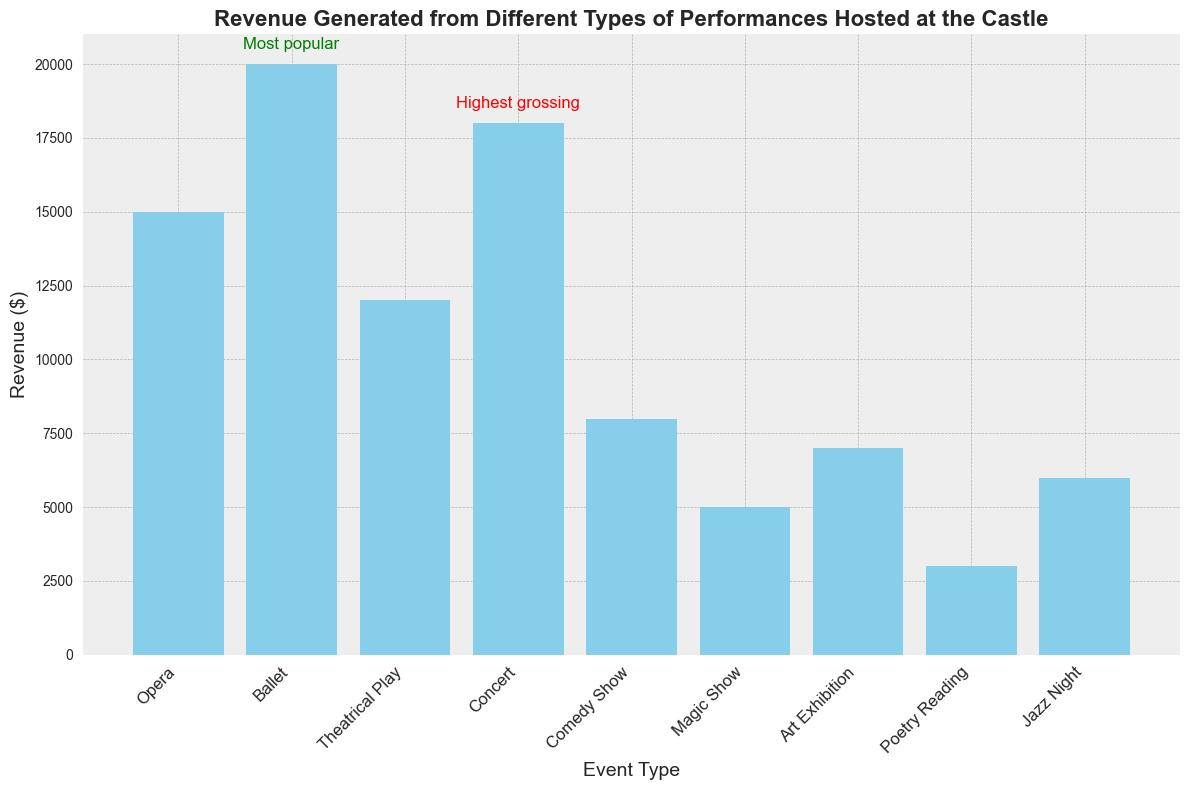Which event type generated the most revenue? By observing the heights of the bars, the Ballet event has the tallest bar indicating it generated the most revenue.
Answer: Ballet What notes are associated with the highest grossing event? The highest grossing event, Ballet, has a note indicated with "Most popular" in green text above its bar.
Answer: Most popular How does the revenue of the Concert compare to the Opera? The Concert generated $18,000, while the Opera generated $15,000. Thus, the Concert generated $3,000 more than the Opera.
Answer: Concert generated $3,000 more What is the revenue difference between the highest grossing event and the lowest grossing event? The Ballet generated the most at $20,000, and the Poetry Reading generated the least at $3,000. The difference is $20,000 - $3,000 = $17,000.
Answer: $17,000 Which events are marked as sponsored in the notes? The Magic Show, Art Exhibition, and Jazz Night all have the note "Sponsored event" associated with them.
Answer: Magic Show, Art Exhibition, Jazz Night What is the total revenue generated by all sponsored events? Adding the revenues of Magic Show ($5,000), Art Exhibition ($7,000), and Jazz Night ($6,000): 5,000 + 7,000 + 6,000 = 18,000.
Answer: $18,000 How does the revenue of the second highest grossing event compare to the highest grossing event? The second highest grossing event is the Concert at $18,000, while the Ballet is the highest at $20,000. The difference is $20,000 - $18,000 = $2,000.
Answer: $2,000 Which event types have notes related to their performance, and what are they? The events with notes are Opera (High demand), Ballet (Most popular), Concert (Highest grossing), Magic Show (Sponsored event), Art Exhibition (Sponsored event), and Jazz Night (Sponsored event).
Answer: Opera, Ballet, Concert, Magic Show, Art Exhibition, Jazz Night How many events generated more than $10,000 but less than $20,000 in revenue? The events falling in this range are Opera ($15,000), Theatrical Play ($12,000), and Concert ($18,000), totaling three events.
Answer: 3 If we sum the revenue of the two events with the green and red annotations, how much is it? The event with the green annotation (Ballet) generated $20,000, and the event with the red annotation (Concert) generated $18,000. Their combined revenue is $20,000 + $18,000 = $38,000.
Answer: $38,000 